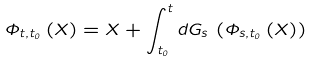Convert formula to latex. <formula><loc_0><loc_0><loc_500><loc_500>\Phi _ { t , t _ { 0 } } \left ( X \right ) = X + \int _ { t _ { 0 } } ^ { t } d G _ { s } \, \left ( \Phi _ { s , t _ { 0 } } \left ( X \right ) \right )</formula> 